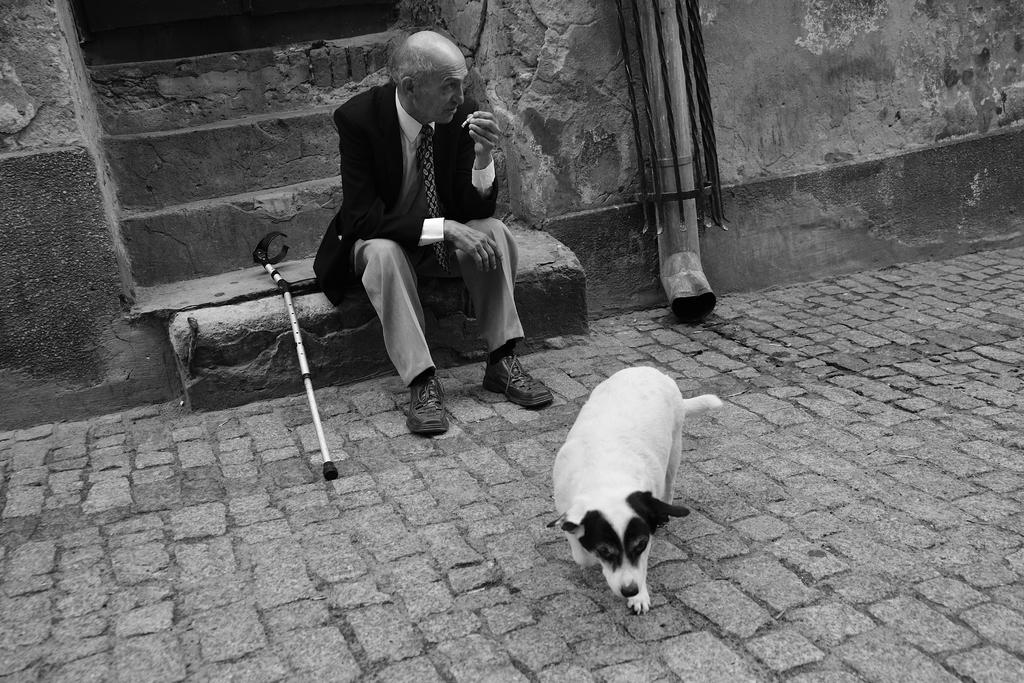What is the person in the image doing? The person is sitting on stairs in the image. Is there any other living creature in the image? Yes, there is a dog in front of the person. What object is beside the person? There is a stick beside the person. What is the color scheme of the image? The image is in black and white. What type of toothbrush is the lawyer using in the image? There is no toothbrush or lawyer present in the image. Can you tell me what key the dog is holding in the image? There is no key present in the image; the dog is simply sitting in front of the person. 